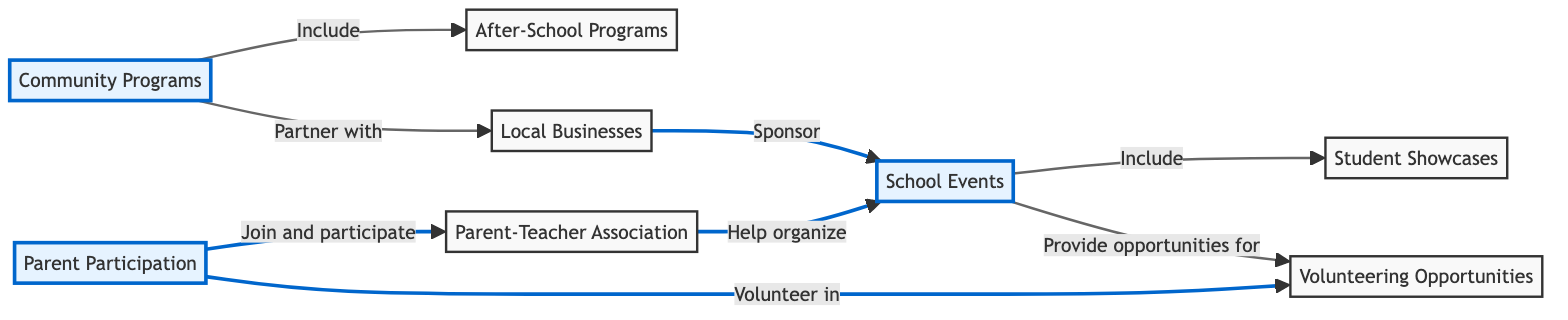What are the three main nodes in the diagram? The three main nodes that represent key areas of involvement are Parent Participation, Community Programs, and School Events. Each of these nodes serves as a central theme in the network of parent and community engagement.
Answer: Parent Participation, Community Programs, School Events How many nodes are present in the diagram? By counting each unique element labeled as a node, we can see there are a total of eight distinct nodes listed. This includes Parent Participation, Community Programs, School Events, Parent-Teacher Association, After-School Programs, Local Businesses, Volunteering Opportunities, and Student Showcases.
Answer: 8 What is the relationship between Parent Participation and the Parent-Teacher Association? The relationship explicitly described in the diagram is that parents join and participate in PTA activities, indicating that the PTA exists as an avenue through which parents can engage further in their children's education.
Answer: Join and participate Which node is directly linked to both Local Businesses and Community Programs? The Community Programs node is directly connected to Local Businesses as it illustrates the partnership role local businesses play in supporting these community initiatives.
Answer: Community Programs How many relationships involve volunteering opportunities? By analyzing the connections, we identify that the Volunteering Opportunities node has three direct relationships: one with Parent Participation and two with School Events. Therefore, there are three relationships that involve volunteering opportunities.
Answer: 3 What do the Local Businesses do for School Events? The diagram shows that Local Businesses sponsor school events, highlighting their role in financially supporting or providing resources for these activities.
Answer: Sponsor Which entity organizes School Events alongside the Parent-Teacher Association? The diagram indicates that both Local Businesses and Parent-Teacher Association are involved in organizing and supporting school events, but the additional participation arises from both the PTA and local businesses sponsoring and helping facilitate these events.
Answer: Local Businesses What type of programs do Community Programs include? The diagram specifies that Community Programs include After-School Programs, indicating a direct relationship between these two nodes that emphasizes how community initiatives extend into educational activities beyond regular school hours.
Answer: After-School Programs 